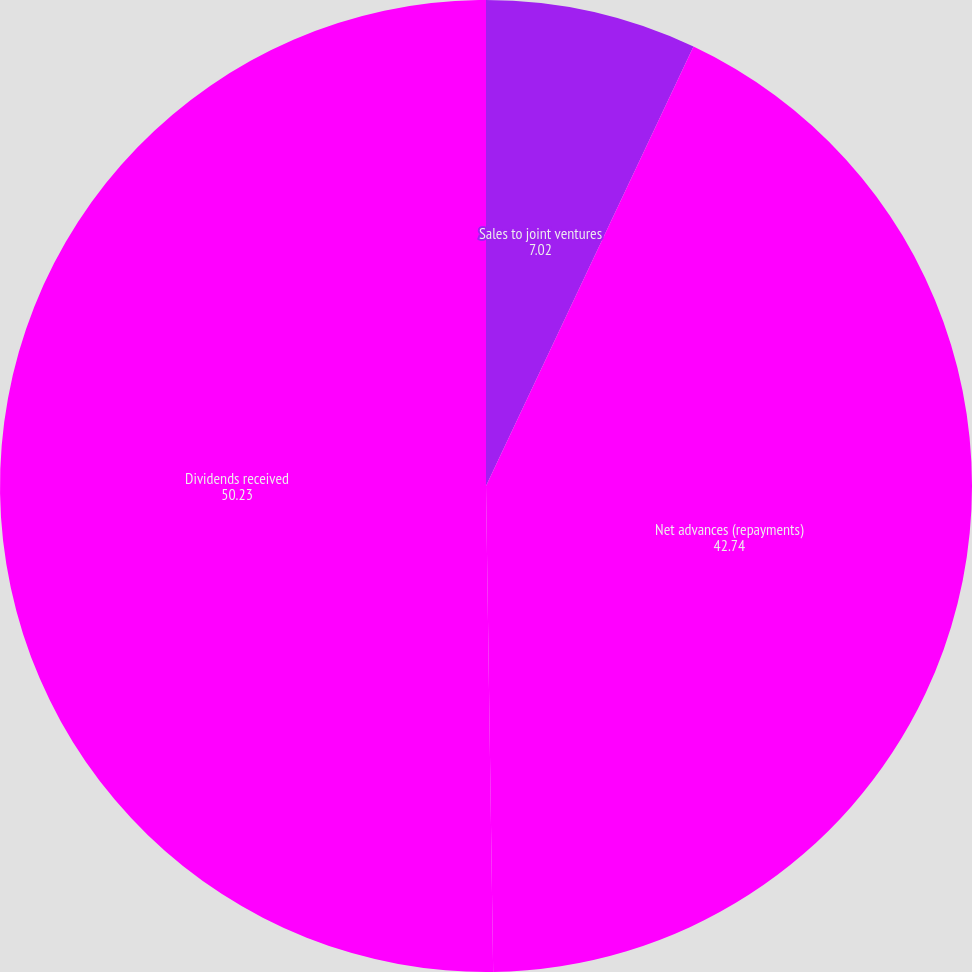<chart> <loc_0><loc_0><loc_500><loc_500><pie_chart><fcel>Sales to joint ventures<fcel>Net advances (repayments)<fcel>Dividends received<nl><fcel>7.02%<fcel>42.74%<fcel>50.23%<nl></chart> 